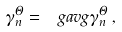Convert formula to latex. <formula><loc_0><loc_0><loc_500><loc_500>\gamma _ { n } ^ { \Theta } = \ g a v g { \gamma _ { n } ^ { \Theta } } \, ,</formula> 